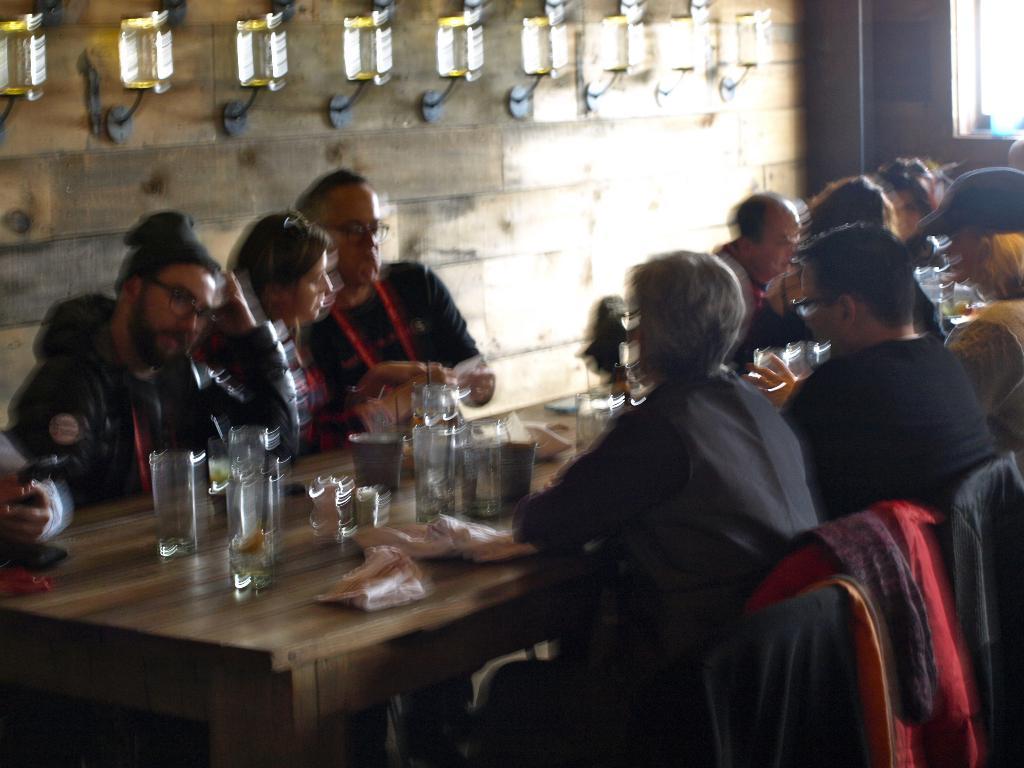Can you describe this image briefly? There are few people sitting on the chair at the table. On the table there are glasses,tissue papers and plates. In the background there is a wall,window and lights. 